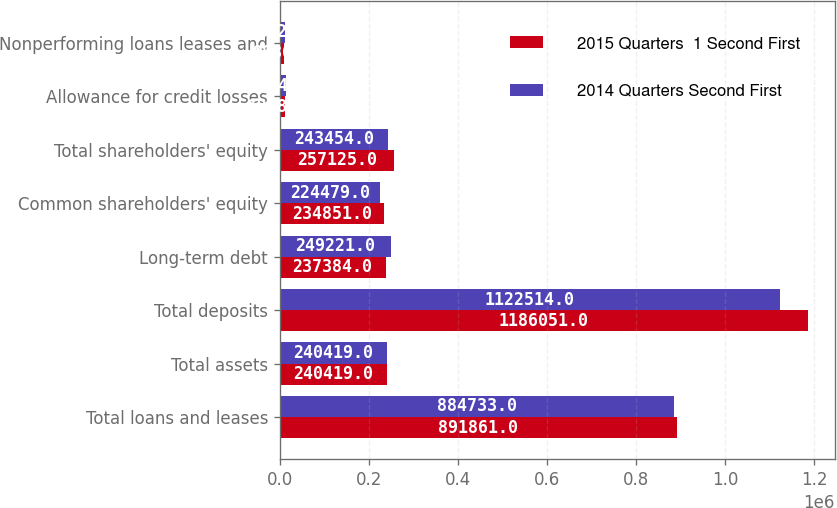Convert chart to OTSL. <chart><loc_0><loc_0><loc_500><loc_500><stacked_bar_chart><ecel><fcel>Total loans and leases<fcel>Total assets<fcel>Total deposits<fcel>Long-term debt<fcel>Common shareholders' equity<fcel>Total shareholders' equity<fcel>Allowance for credit losses<fcel>Nonperforming loans leases and<nl><fcel>2015 Quarters  1 Second First<fcel>891861<fcel>240419<fcel>1.18605e+06<fcel>237384<fcel>234851<fcel>257125<fcel>12880<fcel>9836<nl><fcel>2014 Quarters Second First<fcel>884733<fcel>240419<fcel>1.12251e+06<fcel>249221<fcel>224479<fcel>243454<fcel>14947<fcel>12629<nl></chart> 